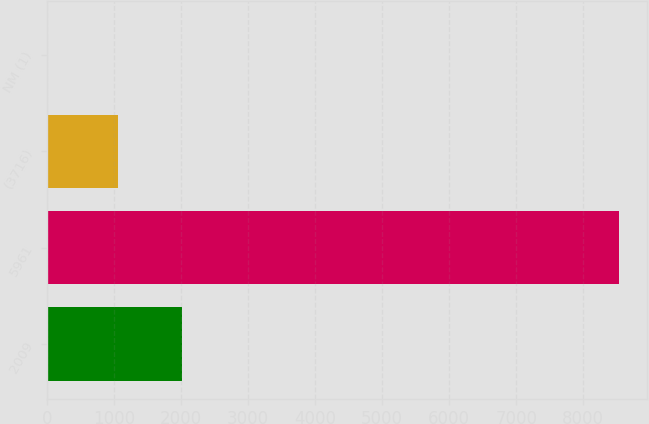Convert chart. <chart><loc_0><loc_0><loc_500><loc_500><bar_chart><fcel>2009<fcel>5961<fcel>(3716)<fcel>NM (1)<nl><fcel>2007<fcel>8531<fcel>1063<fcel>12.5<nl></chart> 